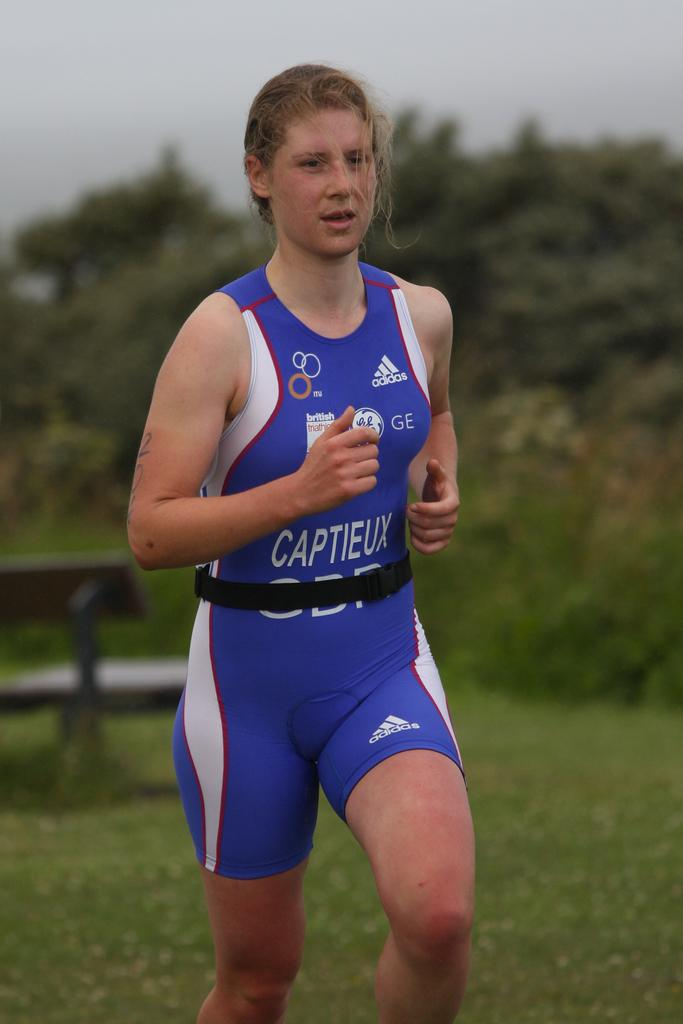Provide a one-sentence caption for the provided image. The advertiser on the shirt is from Adidas. 